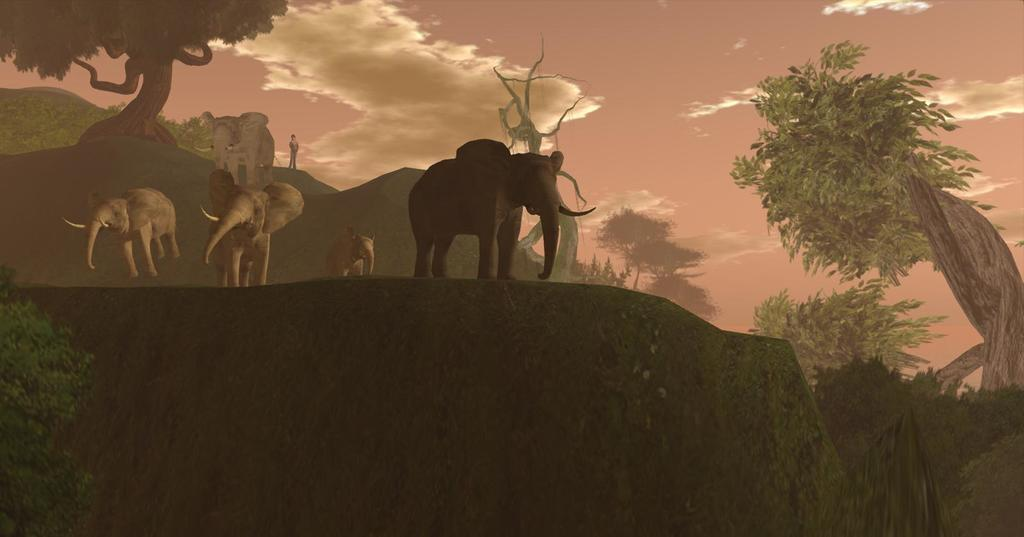What animals can be seen in the image? There are elephants in the image. What type of vegetation is present in the image? There are plants and trees in the image. What is the setting of the image? The image depicts a place. What can be seen in the sky in the image? There are clouds in the sky in the image. What type of boats can be seen in the image? There are no boats present in the image. What is the color of the copper in the image? There is no copper present in the image. 